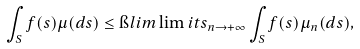Convert formula to latex. <formula><loc_0><loc_0><loc_500><loc_500>\int _ { S } f ( s ) \mu ( d s ) \leq \i l i m \lim i t s _ { n \to + \infty } \int _ { S } f ( s ) \mu _ { n } ( d s ) ,</formula> 